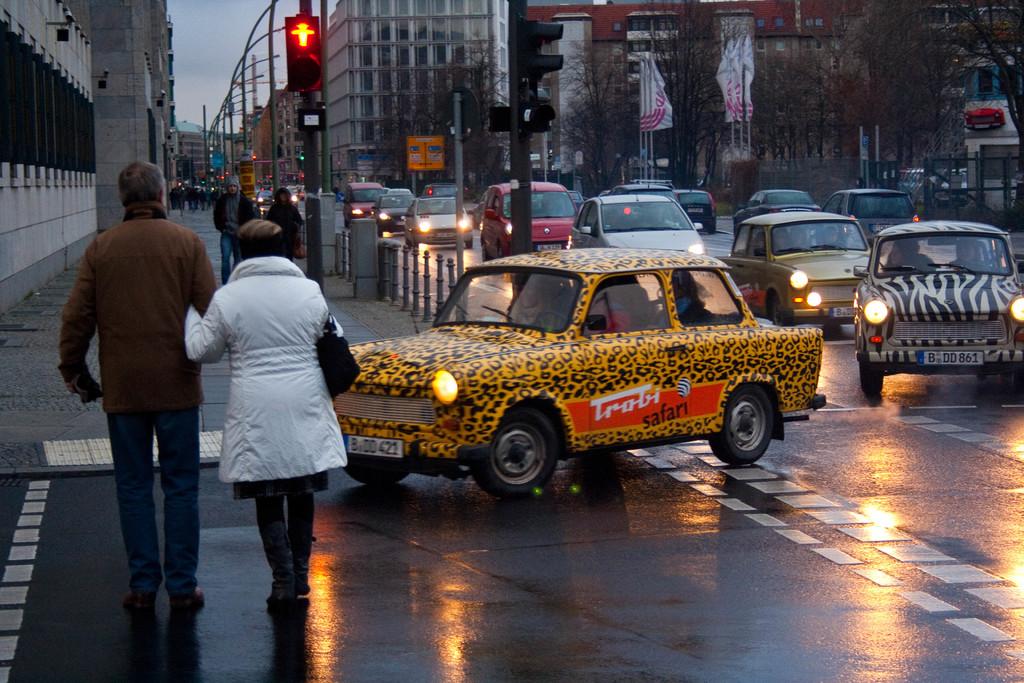What is the license plate number of the ab?
Your response must be concise. Bdd 421. What is on the cab?
Your answer should be compact. Trobi safari. 